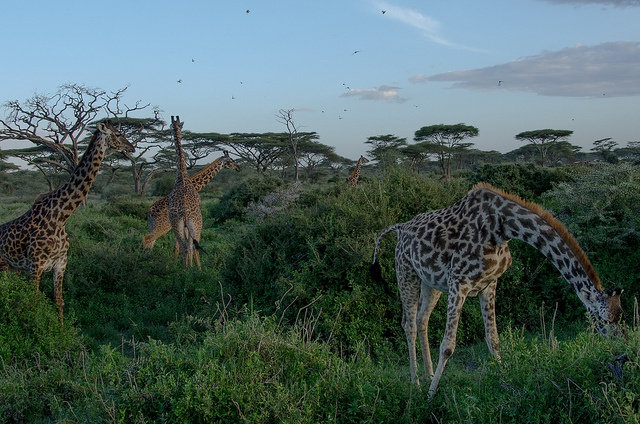Describe the objects in this image and their specific colors. I can see giraffe in lightblue, black, gray, and purple tones, giraffe in lightblue, black, and gray tones, giraffe in lightblue, black, and gray tones, giraffe in lightblue, black, gray, and maroon tones, and bird in lightblue, darkgray, and gray tones in this image. 